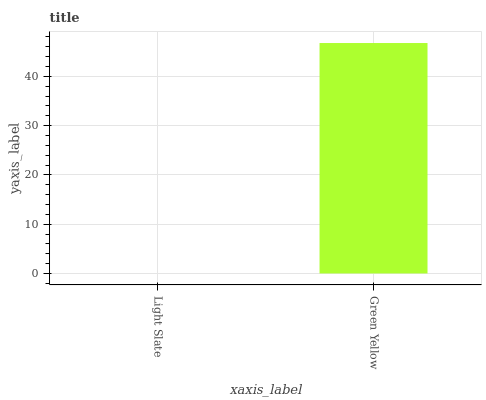Is Green Yellow the minimum?
Answer yes or no. No. Is Green Yellow greater than Light Slate?
Answer yes or no. Yes. Is Light Slate less than Green Yellow?
Answer yes or no. Yes. Is Light Slate greater than Green Yellow?
Answer yes or no. No. Is Green Yellow less than Light Slate?
Answer yes or no. No. Is Green Yellow the high median?
Answer yes or no. Yes. Is Light Slate the low median?
Answer yes or no. Yes. Is Light Slate the high median?
Answer yes or no. No. Is Green Yellow the low median?
Answer yes or no. No. 